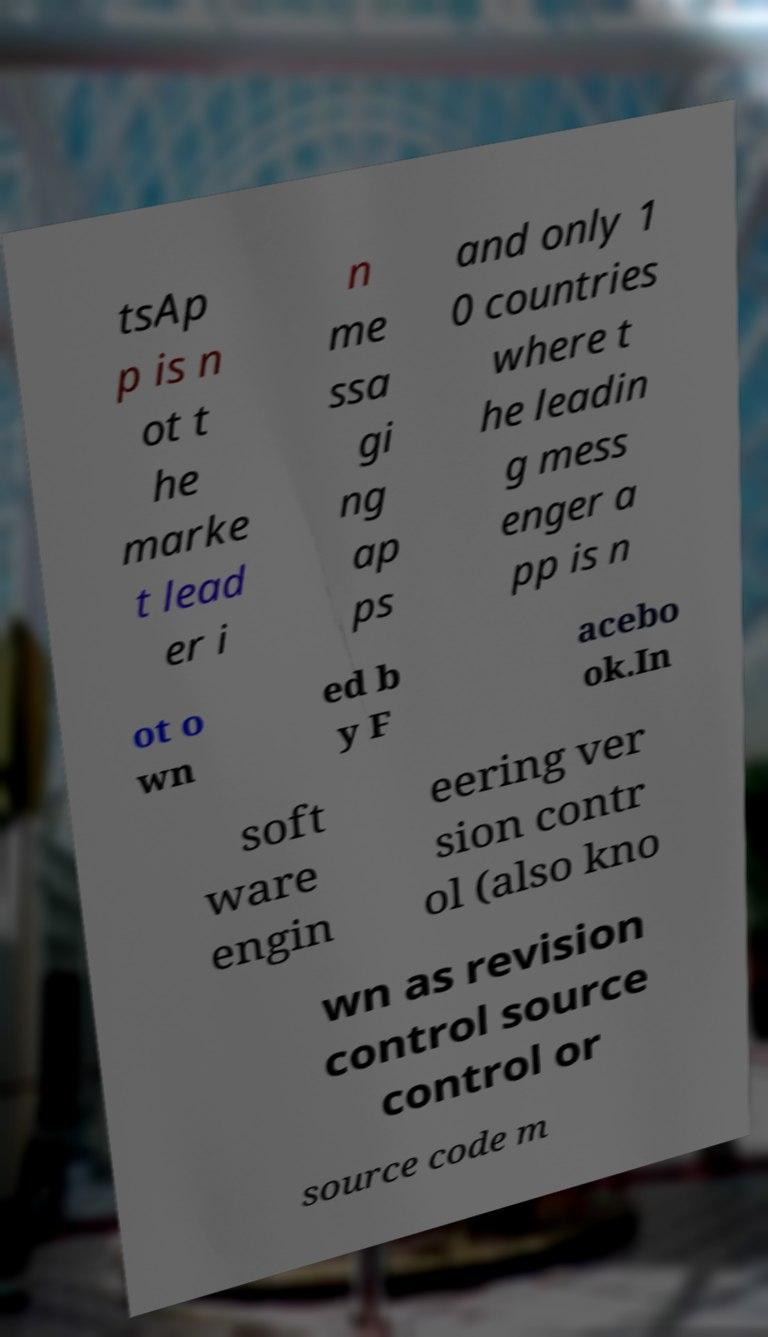I need the written content from this picture converted into text. Can you do that? tsAp p is n ot t he marke t lead er i n me ssa gi ng ap ps and only 1 0 countries where t he leadin g mess enger a pp is n ot o wn ed b y F acebo ok.In soft ware engin eering ver sion contr ol (also kno wn as revision control source control or source code m 